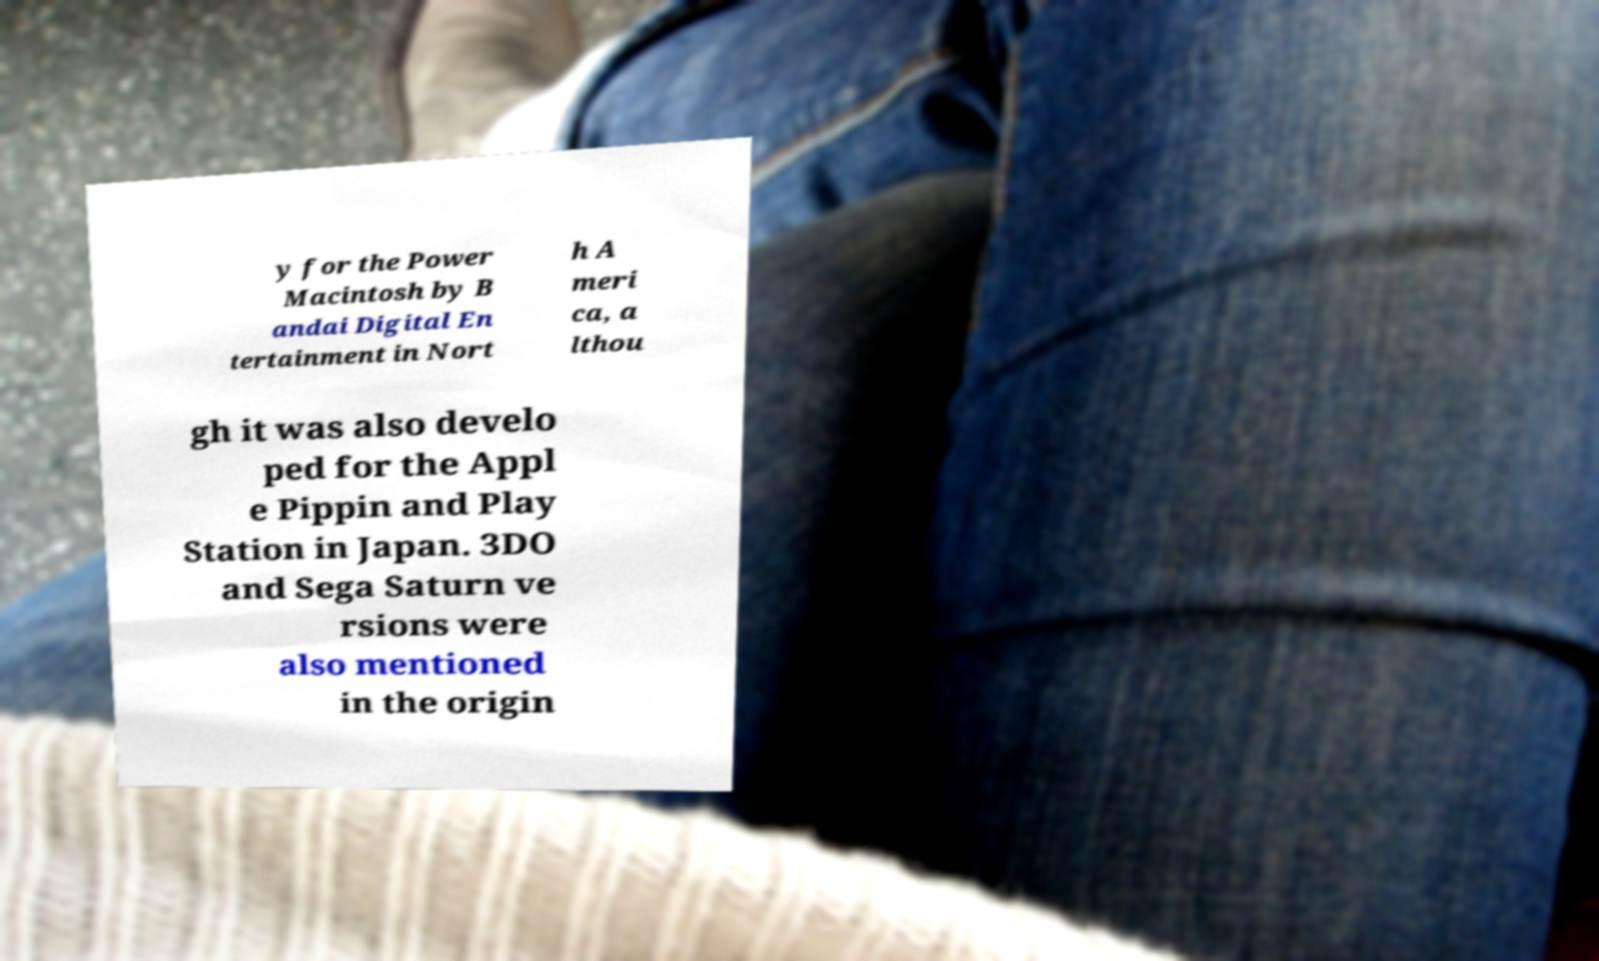Could you extract and type out the text from this image? y for the Power Macintosh by B andai Digital En tertainment in Nort h A meri ca, a lthou gh it was also develo ped for the Appl e Pippin and Play Station in Japan. 3DO and Sega Saturn ve rsions were also mentioned in the origin 